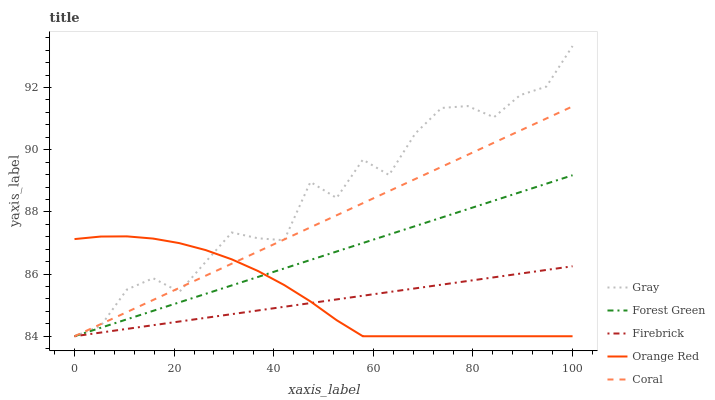Does Firebrick have the minimum area under the curve?
Answer yes or no. Yes. Does Gray have the maximum area under the curve?
Answer yes or no. Yes. Does Forest Green have the minimum area under the curve?
Answer yes or no. No. Does Forest Green have the maximum area under the curve?
Answer yes or no. No. Is Coral the smoothest?
Answer yes or no. Yes. Is Gray the roughest?
Answer yes or no. Yes. Is Forest Green the smoothest?
Answer yes or no. No. Is Forest Green the roughest?
Answer yes or no. No. Does Coral have the lowest value?
Answer yes or no. Yes. Does Gray have the highest value?
Answer yes or no. Yes. Does Forest Green have the highest value?
Answer yes or no. No. Does Forest Green intersect Gray?
Answer yes or no. Yes. Is Forest Green less than Gray?
Answer yes or no. No. Is Forest Green greater than Gray?
Answer yes or no. No. 